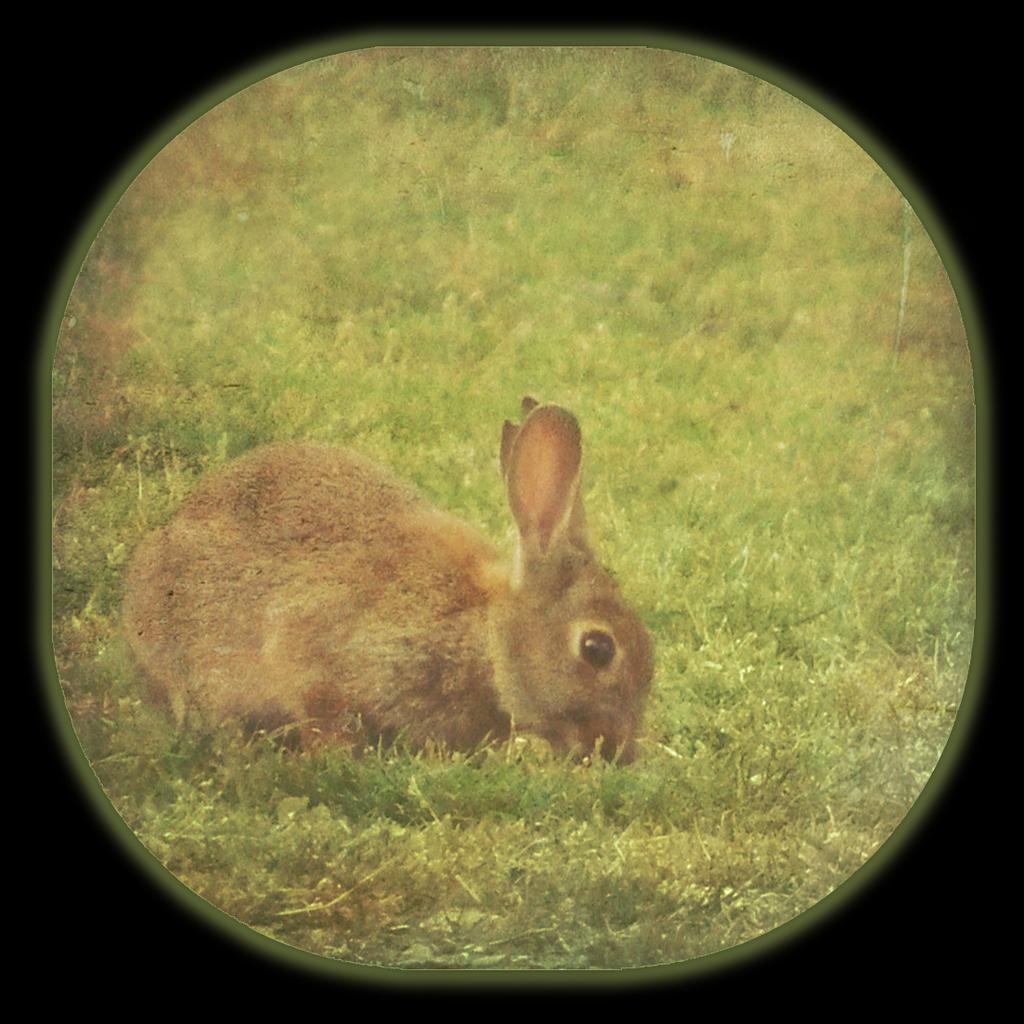Could you give a brief overview of what you see in this image? This image consists of a rabbit in brown color. At the bottom, there is green grass. It looks like it is clicked from a camera lens. 